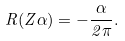Convert formula to latex. <formula><loc_0><loc_0><loc_500><loc_500>R ( Z \alpha ) = - \frac { \alpha } { 2 \pi } .</formula> 